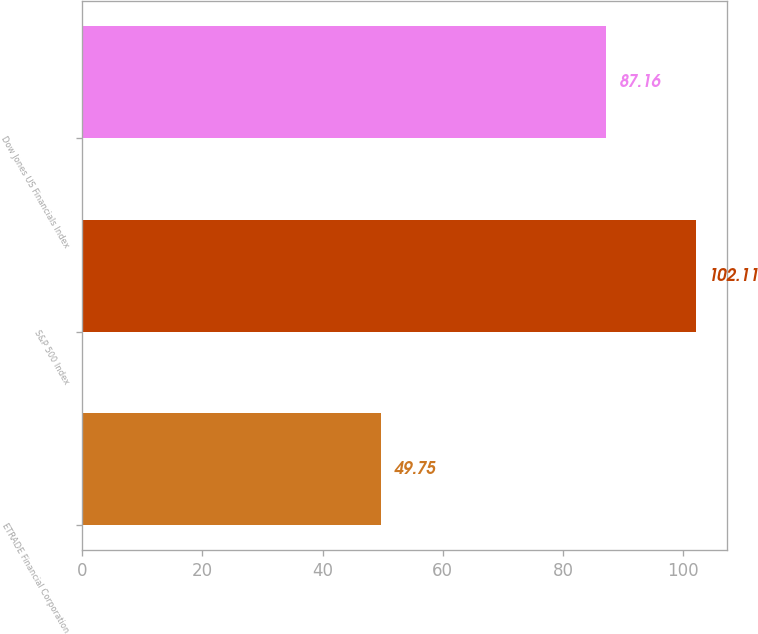Convert chart to OTSL. <chart><loc_0><loc_0><loc_500><loc_500><bar_chart><fcel>ETRADE Financial Corporation<fcel>S&P 500 Index<fcel>Dow Jones US Financials Index<nl><fcel>49.75<fcel>102.11<fcel>87.16<nl></chart> 